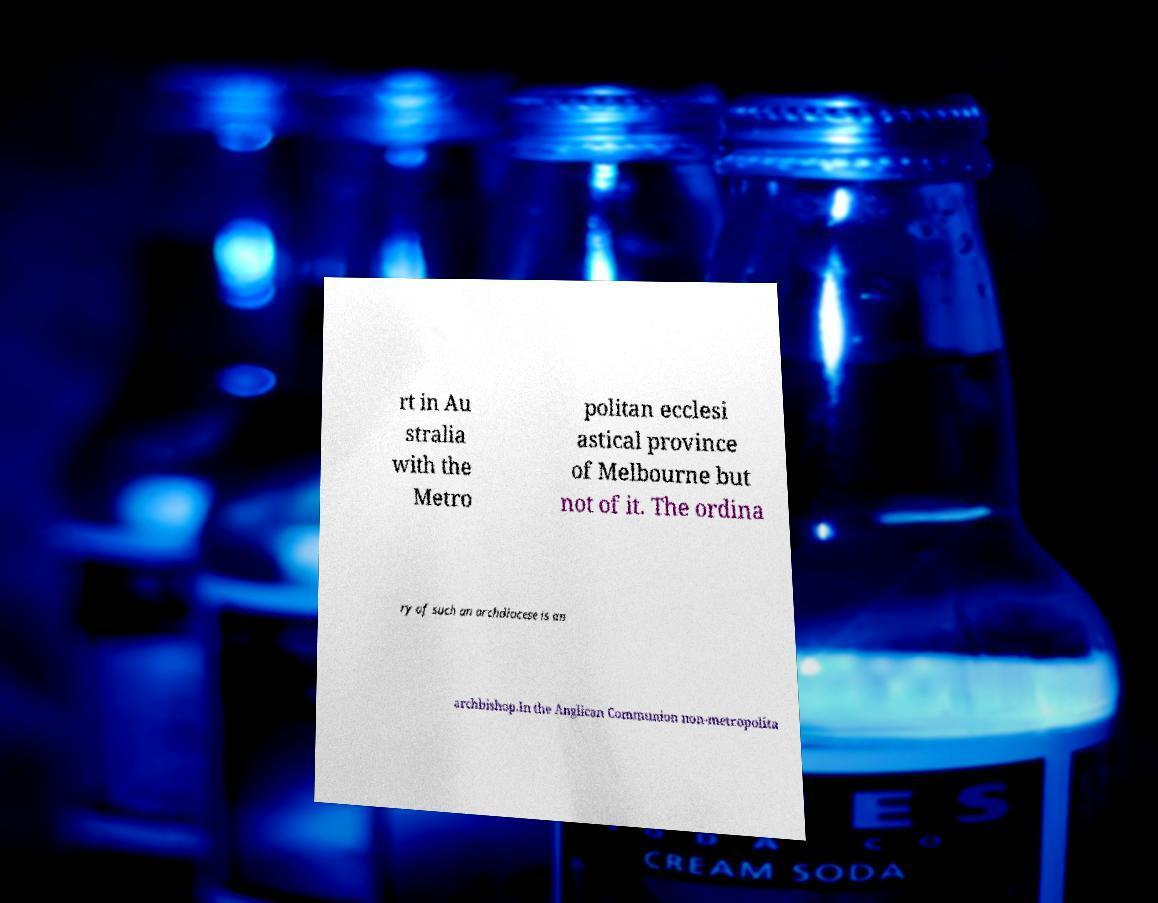Could you extract and type out the text from this image? rt in Au stralia with the Metro politan ecclesi astical province of Melbourne but not of it. The ordina ry of such an archdiocese is an archbishop.In the Anglican Communion non-metropolita 